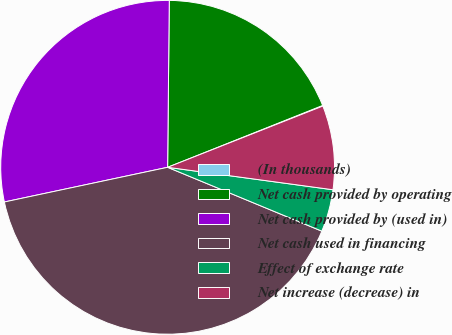<chart> <loc_0><loc_0><loc_500><loc_500><pie_chart><fcel>(In thousands)<fcel>Net cash provided by operating<fcel>Net cash provided by (used in)<fcel>Net cash used in financing<fcel>Effect of exchange rate<fcel>Net increase (decrease) in<nl><fcel>0.06%<fcel>18.8%<fcel>28.49%<fcel>40.42%<fcel>4.1%<fcel>8.13%<nl></chart> 